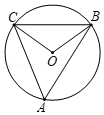First perform reasoning, then finally select the question from the choices in the following format: Answer: xxx.
Question: If angle A is 50 degrees and points A, B, and C all lie on circle O, what is the value of angle OBC?
Choices:
A: 50°
B: 40°
C: 100°
D: 80° Solution: Since angle BAC = 50°, we have angle BOC = 100°. Since BO = CO, we can find angle OBC = (180° - 100°) / 2 = 40°. Therefore, the answer is B.
Answer:B 